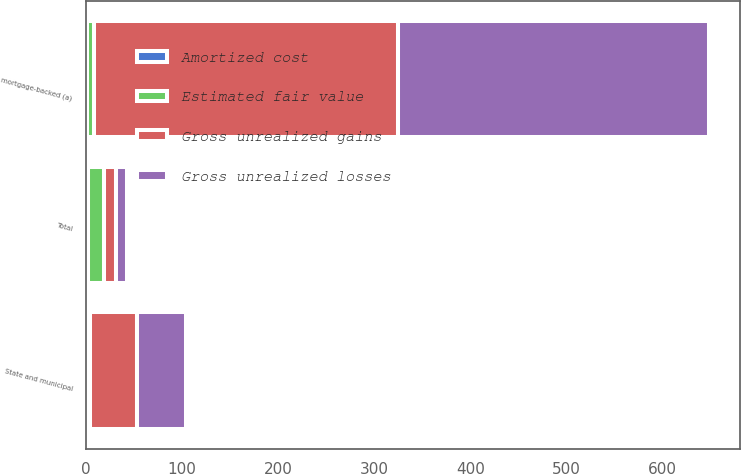Convert chart. <chart><loc_0><loc_0><loc_500><loc_500><stacked_bar_chart><ecel><fcel>State and municipal<fcel>mortgage-backed (a)<fcel>Total<nl><fcel>Gross unrealized losses<fcel>51<fcel>323<fcel>12<nl><fcel>Amortized cost<fcel>1<fcel>1<fcel>2<nl><fcel>Estimated fair value<fcel>3<fcel>7<fcel>17<nl><fcel>Gross unrealized gains<fcel>49<fcel>317<fcel>12<nl></chart> 